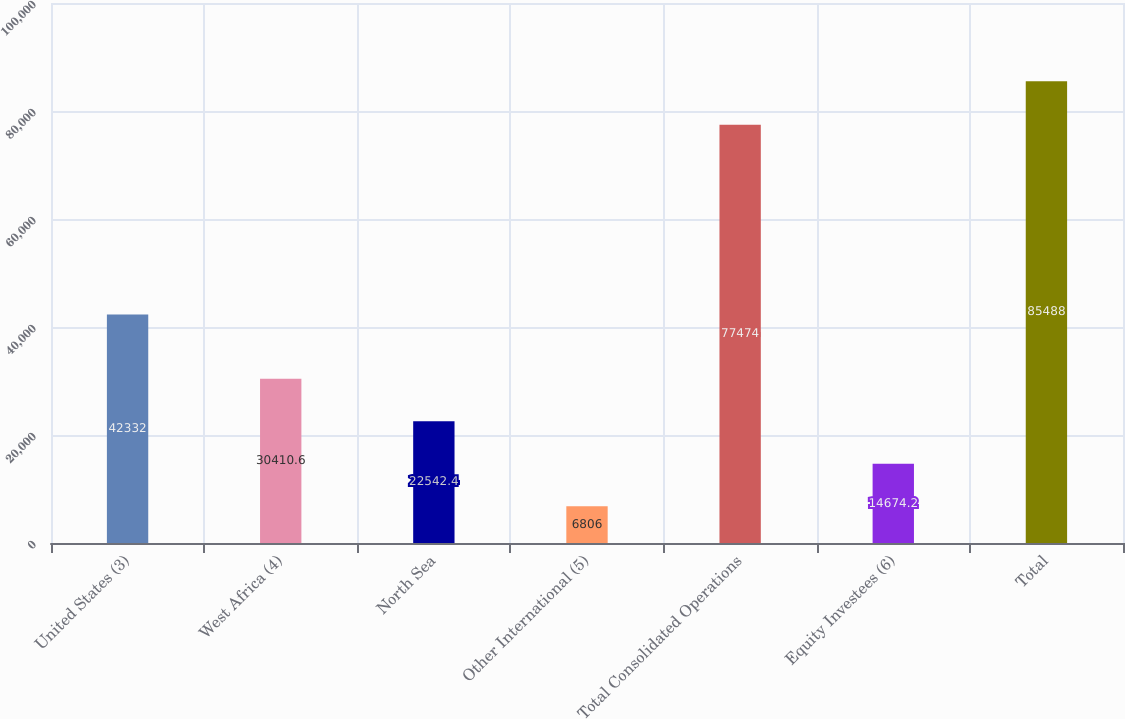<chart> <loc_0><loc_0><loc_500><loc_500><bar_chart><fcel>United States (3)<fcel>West Africa (4)<fcel>North Sea<fcel>Other International (5)<fcel>Total Consolidated Operations<fcel>Equity Investees (6)<fcel>Total<nl><fcel>42332<fcel>30410.6<fcel>22542.4<fcel>6806<fcel>77474<fcel>14674.2<fcel>85488<nl></chart> 